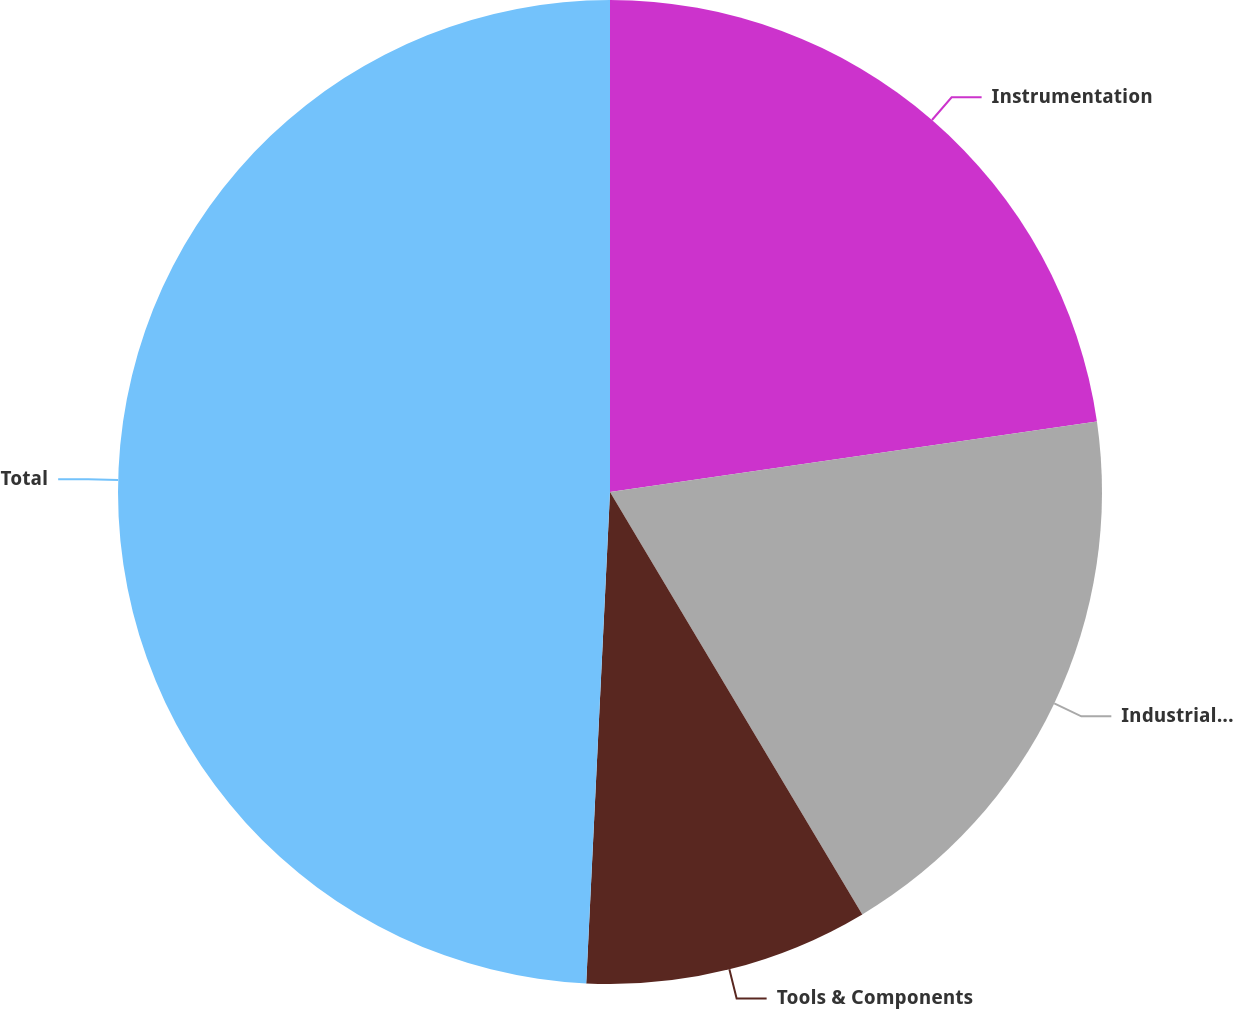<chart> <loc_0><loc_0><loc_500><loc_500><pie_chart><fcel>Instrumentation<fcel>Industrial Technologies<fcel>Tools & Components<fcel>Total<nl><fcel>22.71%<fcel>18.72%<fcel>9.34%<fcel>49.23%<nl></chart> 